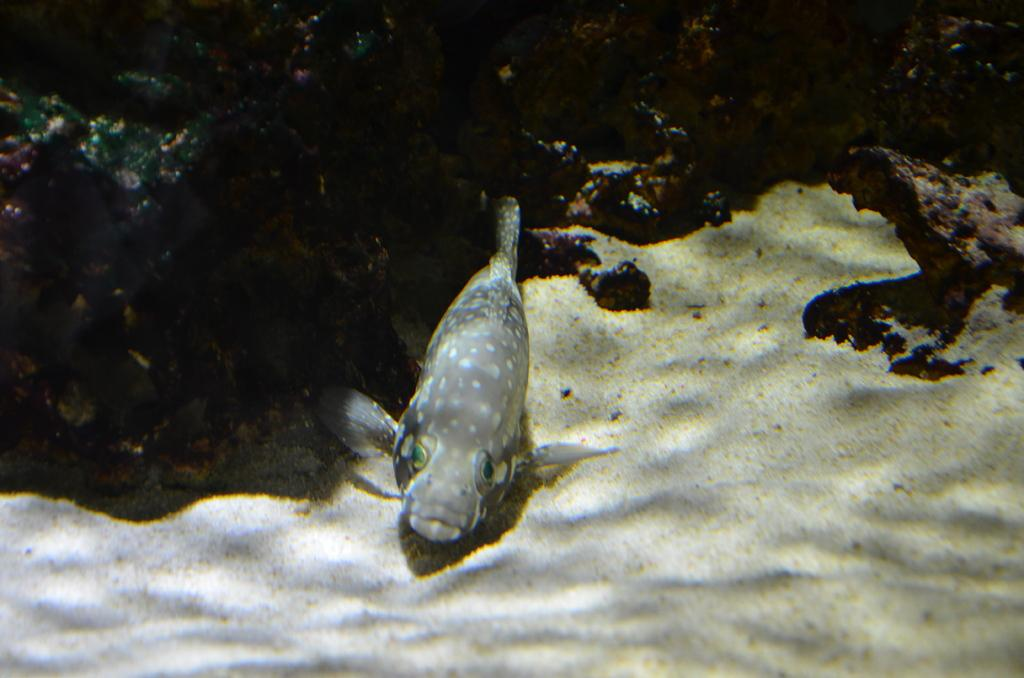What is in the water in the image? There is a fish in the water. What type of terrain is visible on the ground? There is sand on the ground. What can be seen in the background of the image? There are rocks in the background. How many kittens are participating in the protest in the image? There are no kittens or protests present in the image; it features a fish in the water, sand on the ground, and rocks in the background. 